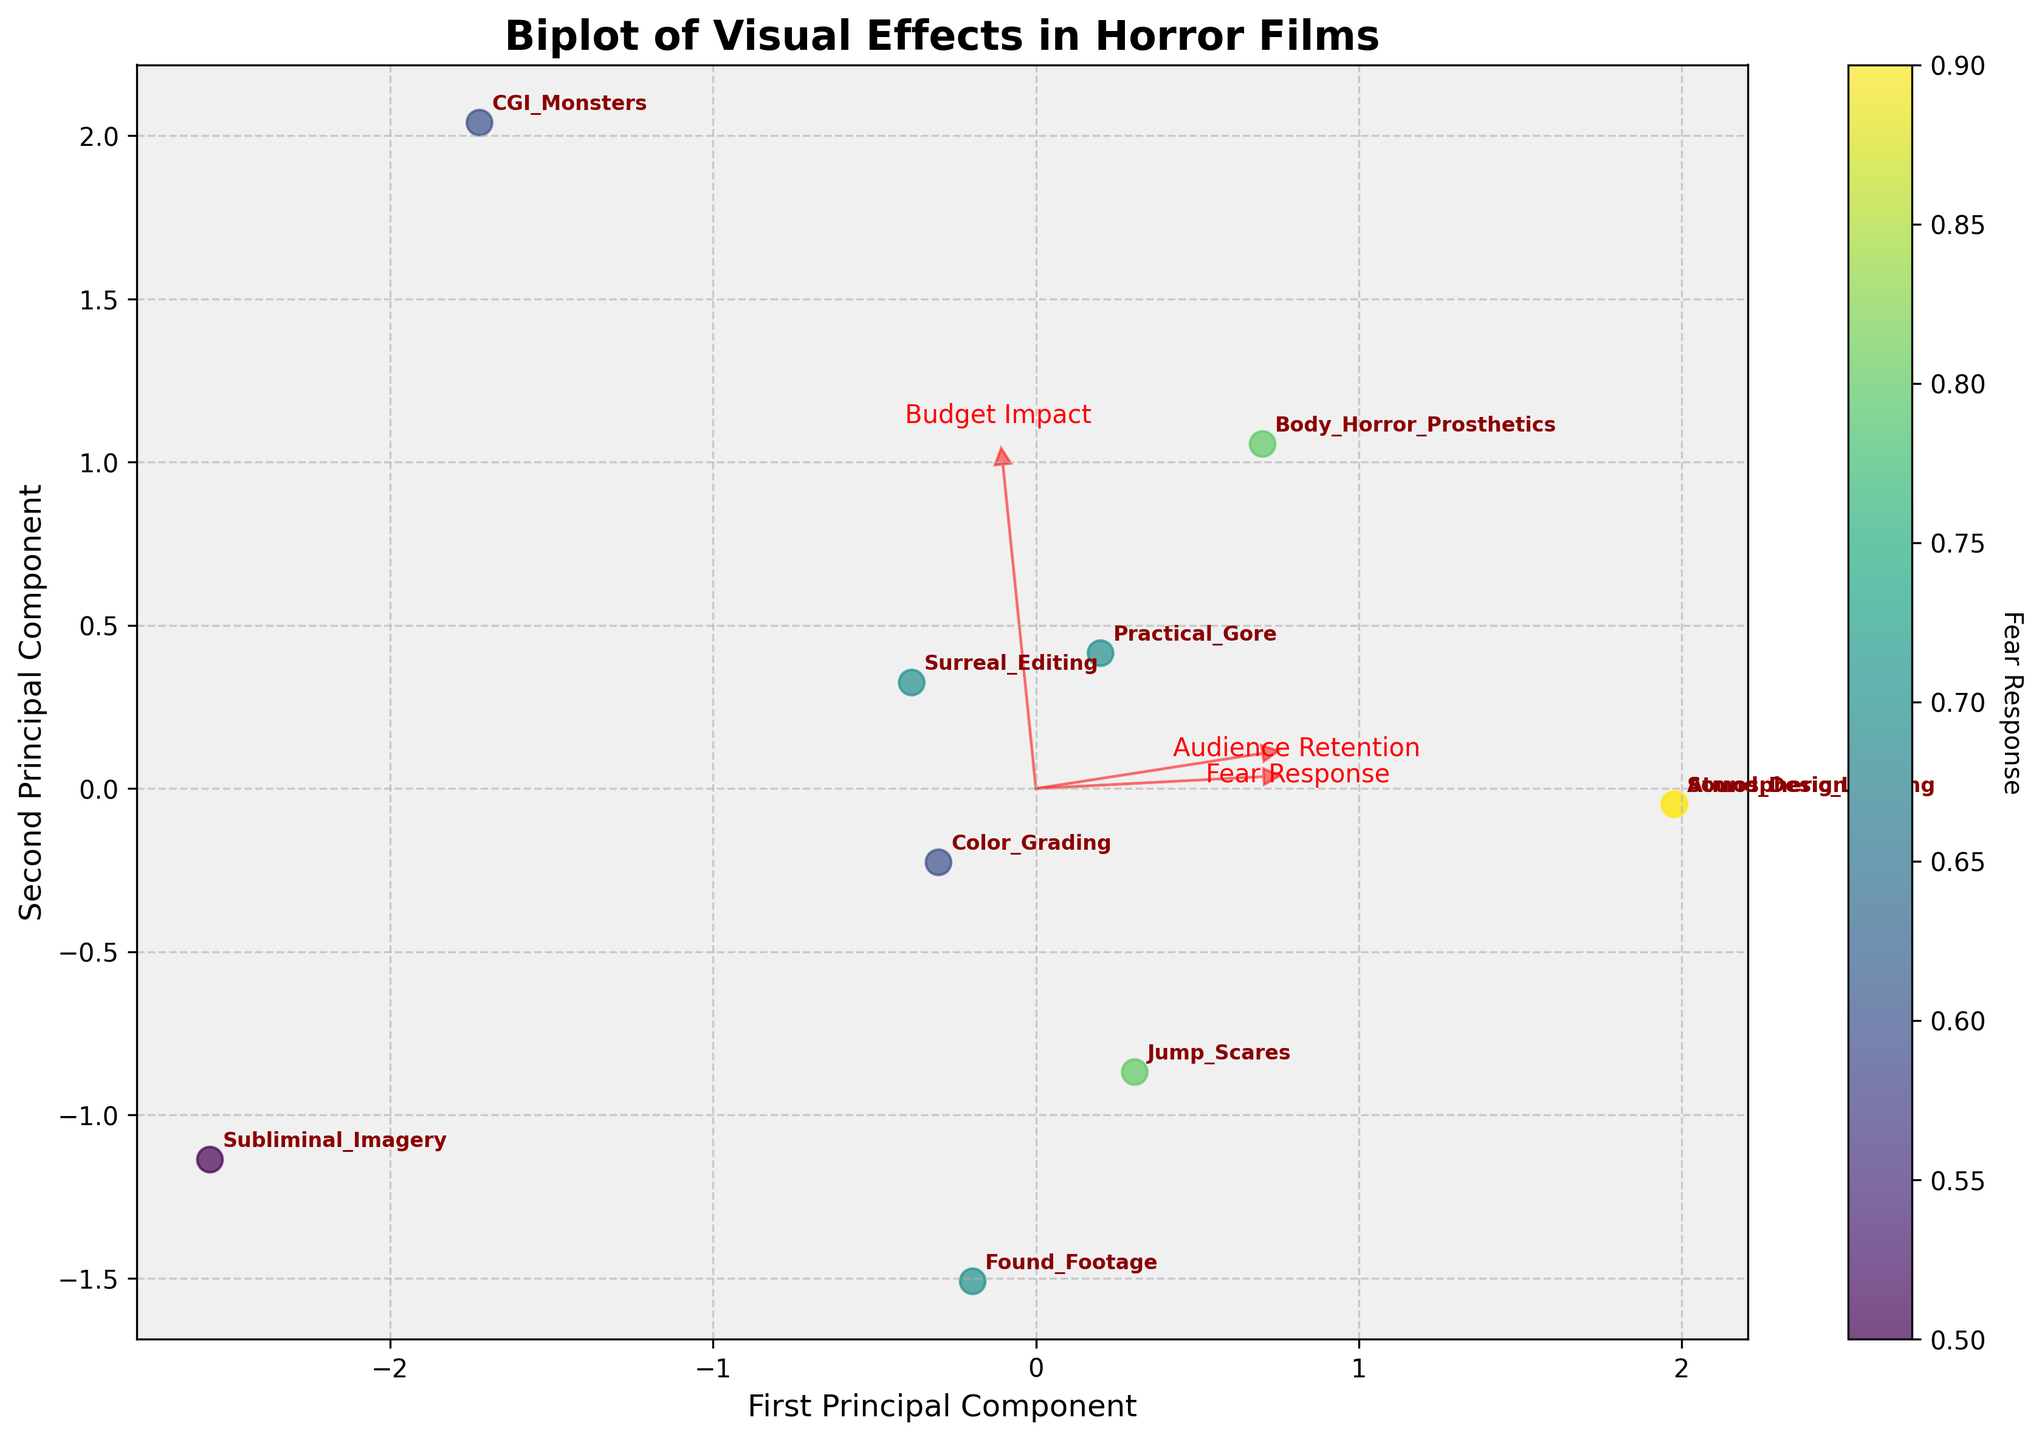what is the title of the plot? The title of the plot is usually located at the top center of the figure and helps in understanding what the plot represents. In this case, it reads "Biplot of Visual Effects in Horror Films."
Answer: Biplot of Visual Effects in Horror Films how many visual effects techniques are plotted? By counting the number of labeled data points or annotations in the plot, we can see that there are 10 visual effects techniques plotted.
Answer: 10 which visual effects techniques are closest to each other? By examining the positions of the labeled points, "Found Footage" and "Surreal Editing" are the closest to each other in the transformed PCA space.
Answer: Found Footage and Surreal Editing which visual effect has the highest 'Fear Response'? The color bar indicates 'Fear Response,' where darker colors represent higher values. "Atmospheric Lighting" has the darkest color, corresponding to the highest 'Fear Response' value.
Answer: Atmospheric Lighting which principal component explains more variance in the data? The eigenvectors' lengths and the wider spread along the first principal component axis indicate it explains more variance compared to the second principal component.
Answer: First Principal Component which visual effect is most associated with 'Audience Retention'? The direction and proximity of the data points to the 'Audience Retention' arrow show that "Atmospheric Lighting" and "Sound Design" are the closest, suggesting high 'Audience Retention.'
Answer: Atmospheric Lighting and Sound Design how does 'Budget Impact' correlate with other features? The 'Budget Impact' arrow points in the opposite direction to many data points. This indicates a negative correlation with 'Fear Response' and 'Audience Retention' since these points cluster away from 'Budget Impact.'
Answer: Negatively correlated which two visual effects are most different in terms of 'Fear Response'? "Atmospheric Lighting" and "Subliminal Imagery" are positioned far apart on the color gradient of the 'Fear Response' color bar, indicating the most difference between these techniques.
Answer: Atmospheric Lighting and Subliminal Imagery what is the color range in the plot? The color range, depicted by the color bar on the right, spans from light yellow to dark purple, indicating varying levels of 'Fear Response' from low to high.
Answer: Light yellow to dark purple which visual effect technique has similar 'Fear Response' to 'Practical Gore'? The point annotations and similar color shading connect "Practical Gore" closely with "Found Footage," suggesting similar 'Fear Response' values.
Answer: Found Footage 